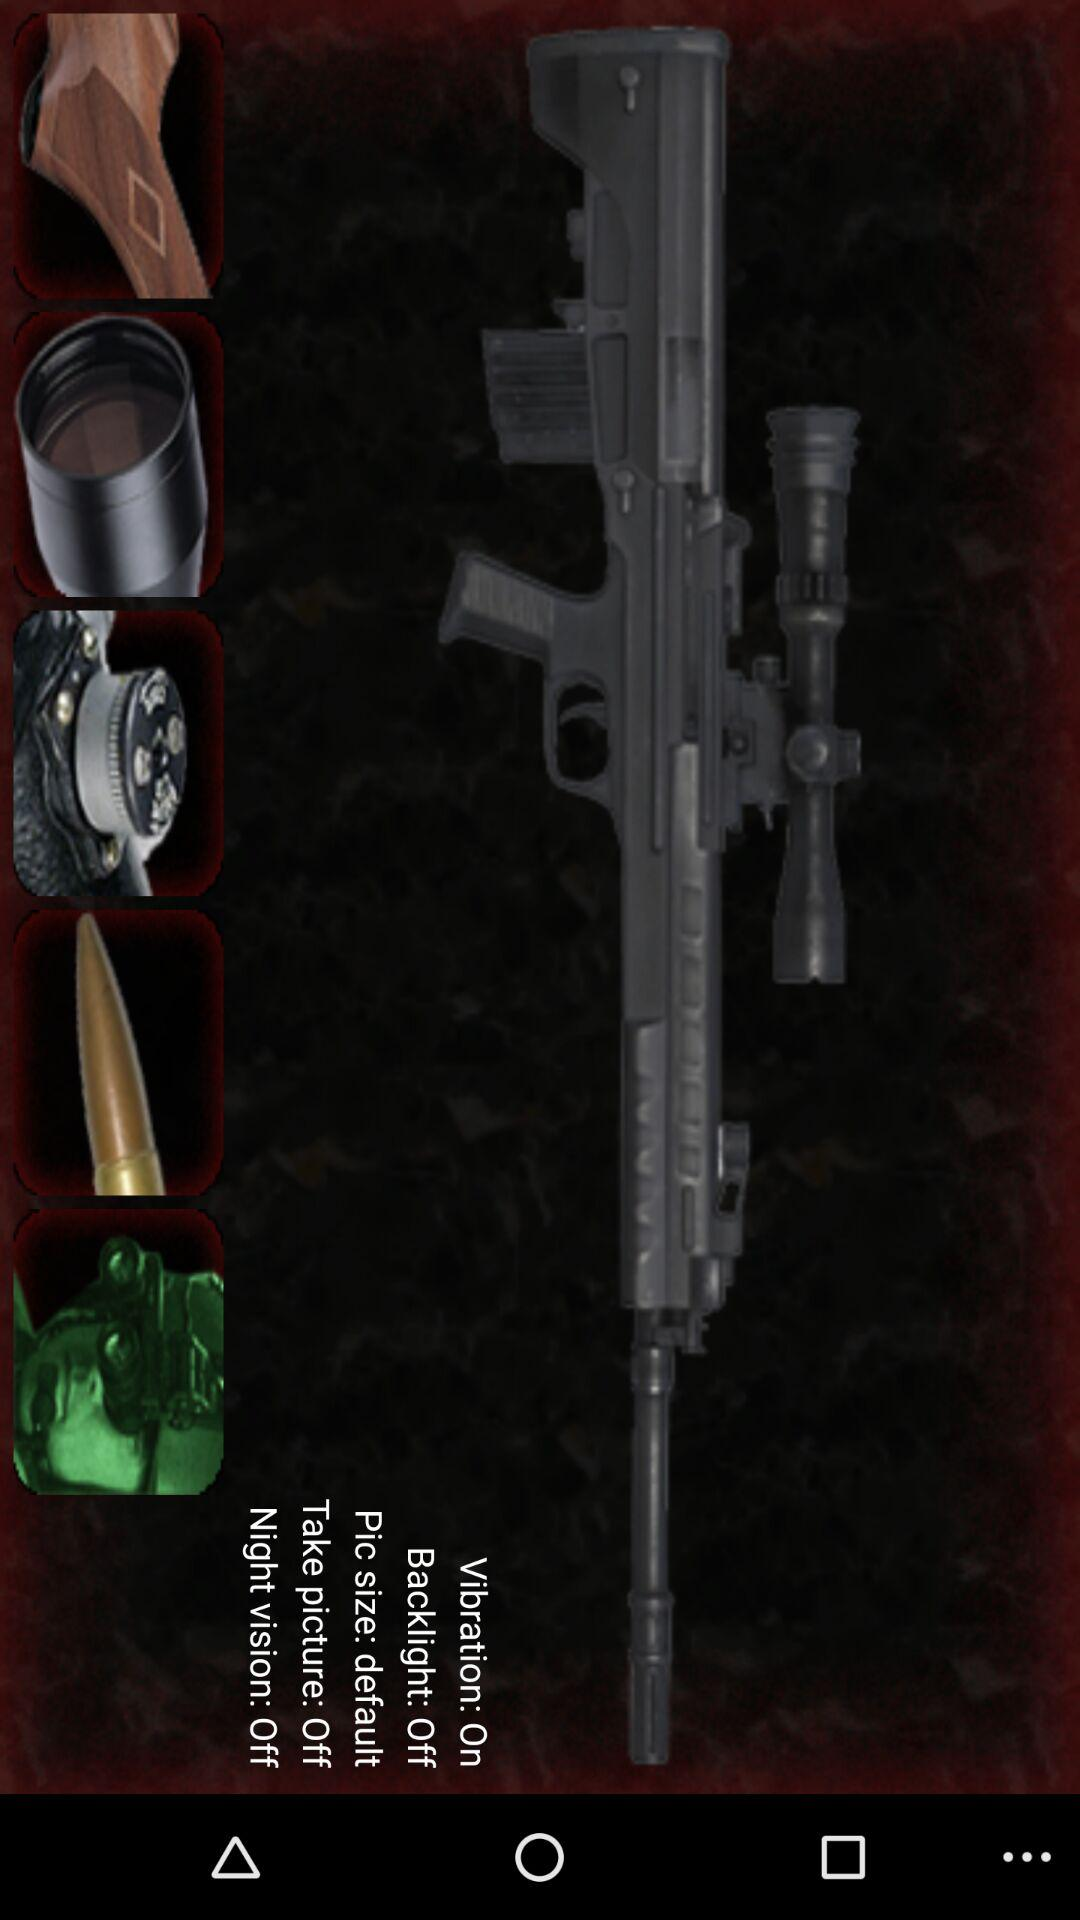What is the status of "Backlight"? The status is "off". 